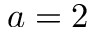<formula> <loc_0><loc_0><loc_500><loc_500>a = 2</formula> 